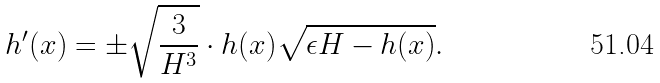Convert formula to latex. <formula><loc_0><loc_0><loc_500><loc_500>h ^ { \prime } ( x ) = \pm \sqrt { \frac { 3 } { H ^ { 3 } } } \cdot h ( x ) \sqrt { \epsilon H - h ( x ) } .</formula> 